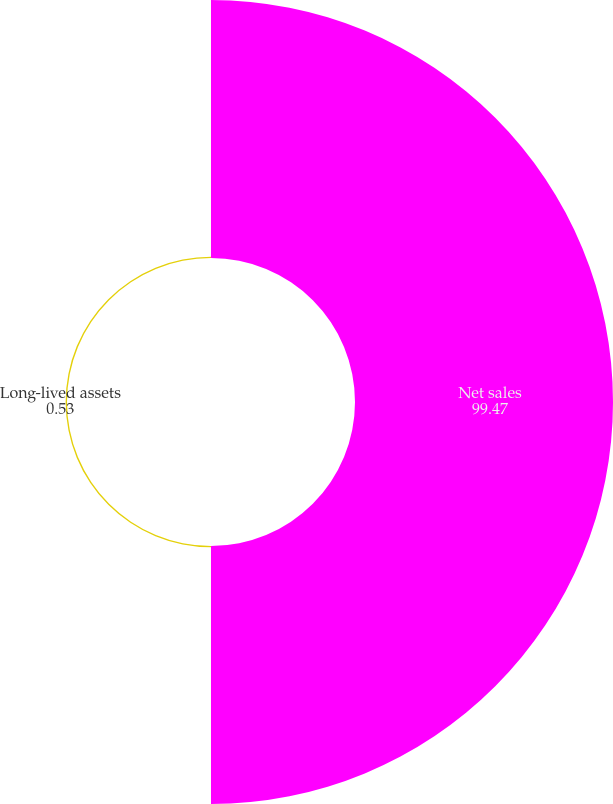Convert chart. <chart><loc_0><loc_0><loc_500><loc_500><pie_chart><fcel>Net sales<fcel>Long-lived assets<nl><fcel>99.47%<fcel>0.53%<nl></chart> 